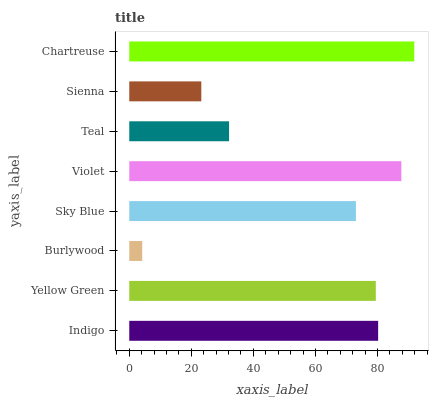Is Burlywood the minimum?
Answer yes or no. Yes. Is Chartreuse the maximum?
Answer yes or no. Yes. Is Yellow Green the minimum?
Answer yes or no. No. Is Yellow Green the maximum?
Answer yes or no. No. Is Indigo greater than Yellow Green?
Answer yes or no. Yes. Is Yellow Green less than Indigo?
Answer yes or no. Yes. Is Yellow Green greater than Indigo?
Answer yes or no. No. Is Indigo less than Yellow Green?
Answer yes or no. No. Is Yellow Green the high median?
Answer yes or no. Yes. Is Sky Blue the low median?
Answer yes or no. Yes. Is Sienna the high median?
Answer yes or no. No. Is Burlywood the low median?
Answer yes or no. No. 